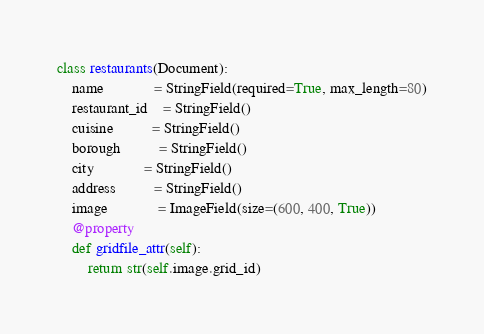Convert code to text. <code><loc_0><loc_0><loc_500><loc_500><_Python_>
class restaurants(Document):
    name             = StringField(required=True, max_length=80)
    restaurant_id    = StringField()
    cuisine          = StringField()
    borough          = StringField()
    city             = StringField()
    address          = StringField()
    image			 = ImageField(size=(600, 400, True))
    @property
    def gridfile_attr(self):
		return str(self.image.grid_id)
</code> 